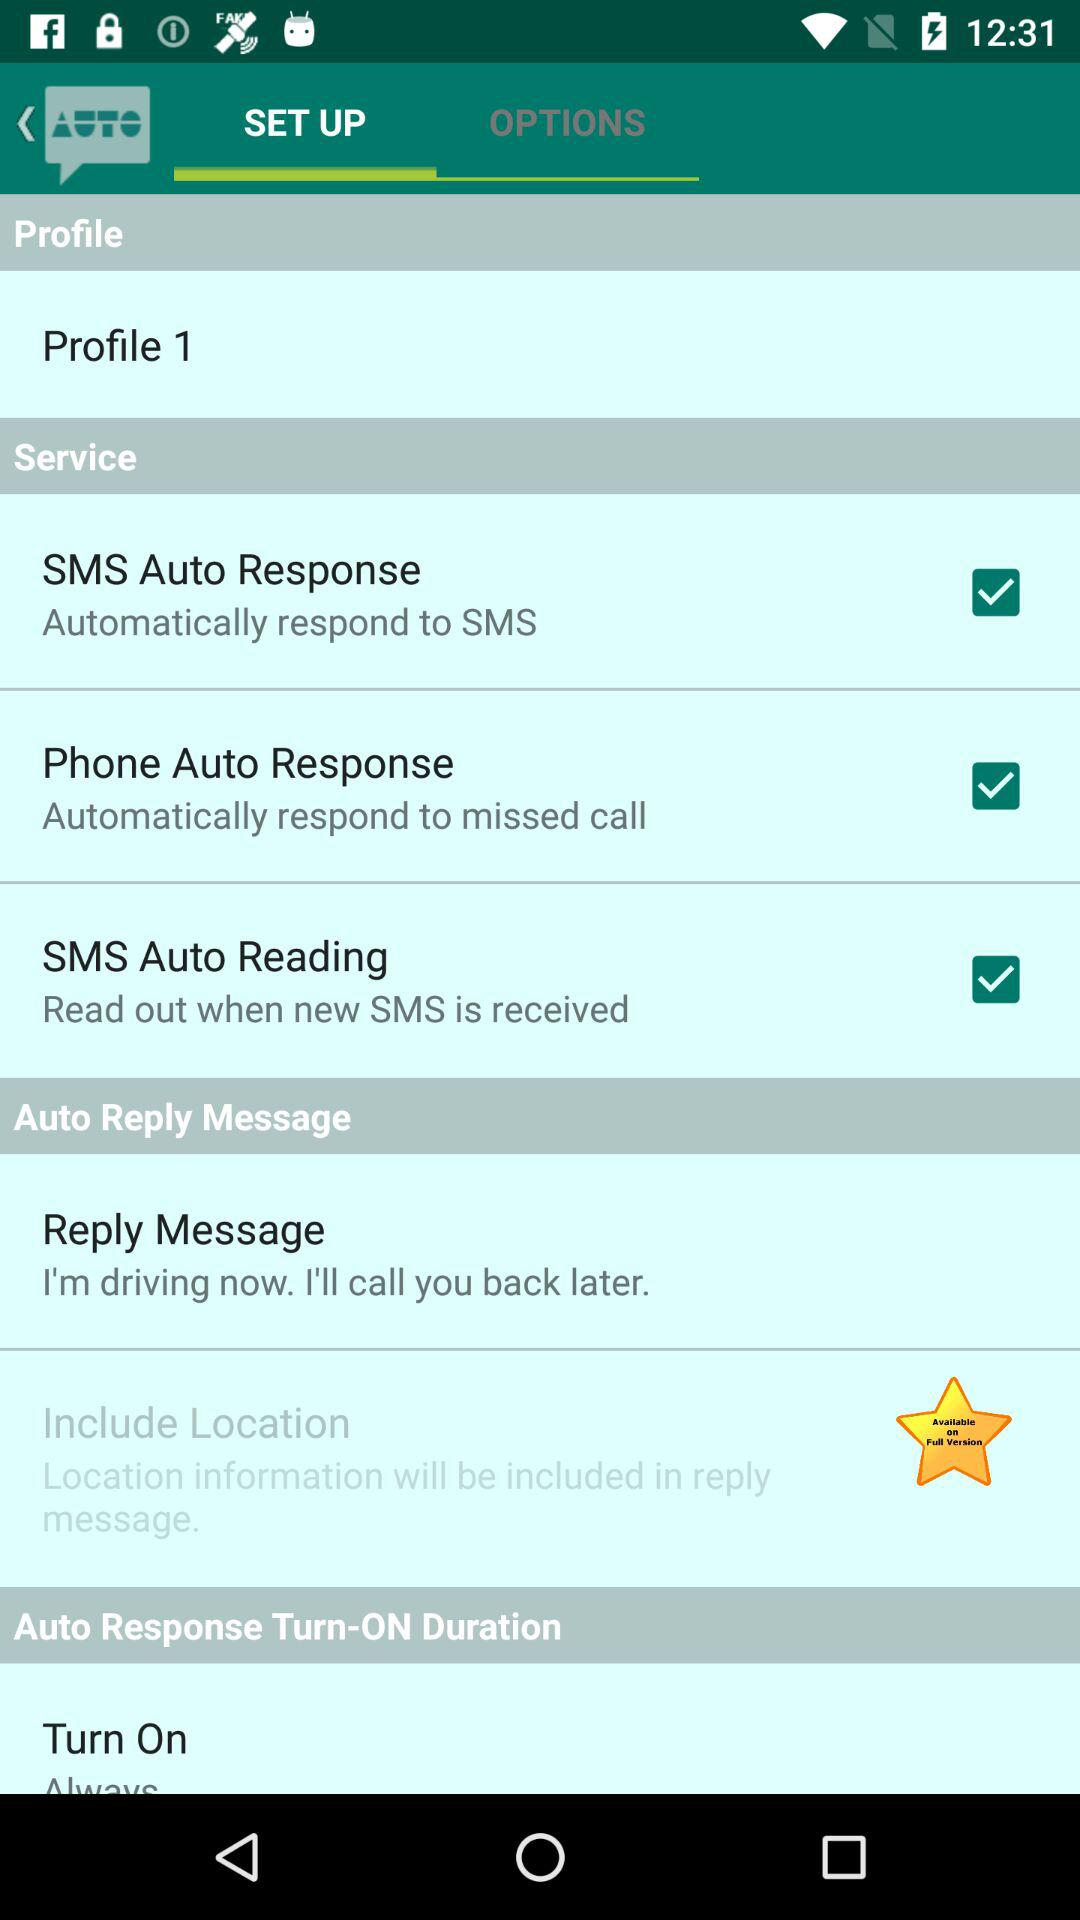What is the profile name? The profile name is "Profile 1". 